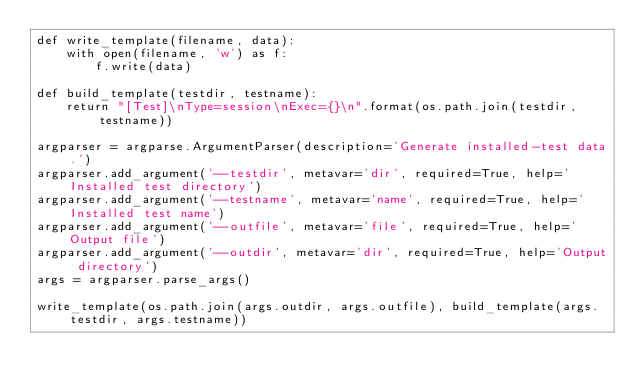Convert code to text. <code><loc_0><loc_0><loc_500><loc_500><_Python_>def write_template(filename, data):
    with open(filename, 'w') as f:
        f.write(data)

def build_template(testdir, testname):
    return "[Test]\nType=session\nExec={}\n".format(os.path.join(testdir, testname))

argparser = argparse.ArgumentParser(description='Generate installed-test data.')
argparser.add_argument('--testdir', metavar='dir', required=True, help='Installed test directory')
argparser.add_argument('--testname', metavar='name', required=True, help='Installed test name')
argparser.add_argument('--outfile', metavar='file', required=True, help='Output file')
argparser.add_argument('--outdir', metavar='dir', required=True, help='Output directory')
args = argparser.parse_args()

write_template(os.path.join(args.outdir, args.outfile), build_template(args.testdir, args.testname))
</code> 